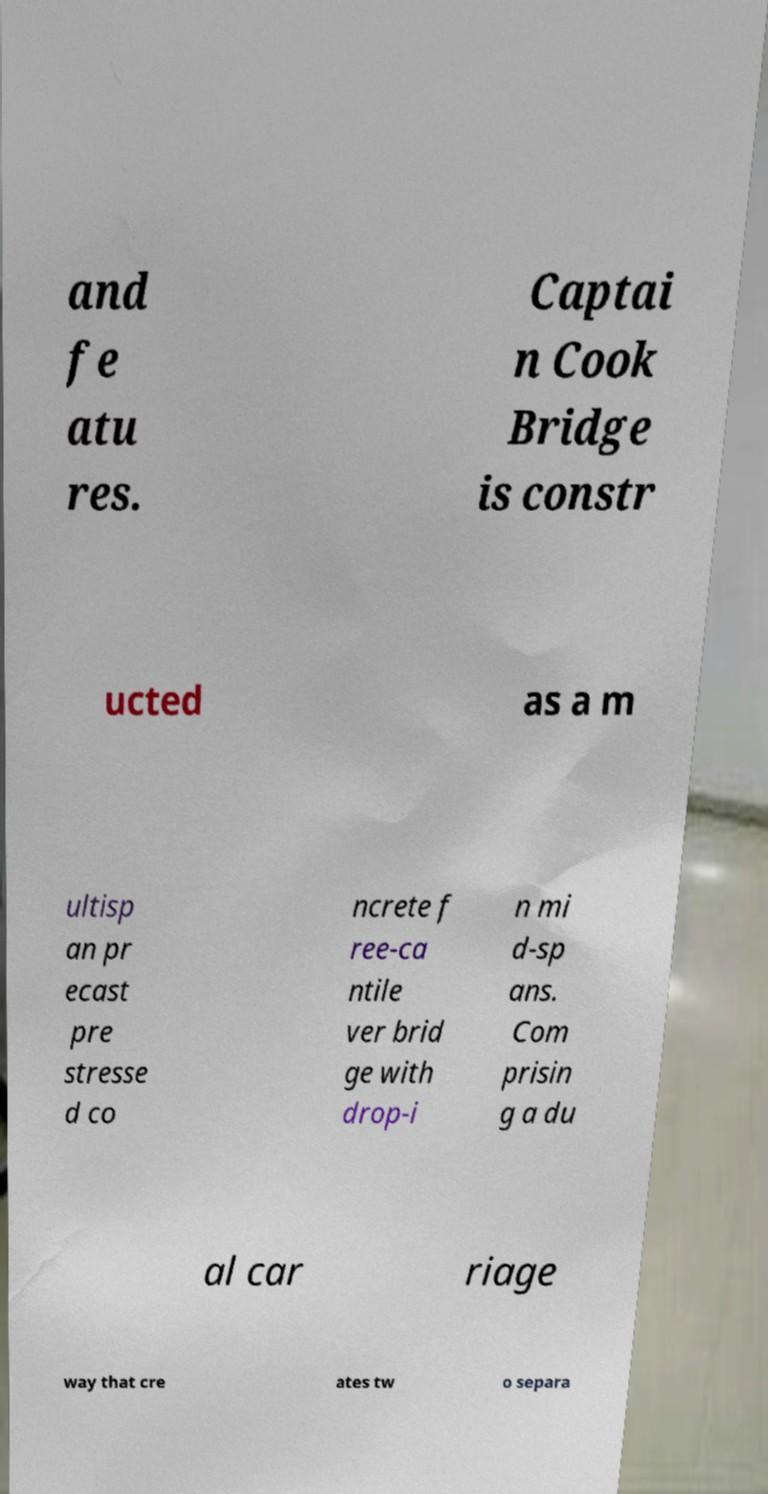Please read and relay the text visible in this image. What does it say? and fe atu res. Captai n Cook Bridge is constr ucted as a m ultisp an pr ecast pre stresse d co ncrete f ree-ca ntile ver brid ge with drop-i n mi d-sp ans. Com prisin g a du al car riage way that cre ates tw o separa 